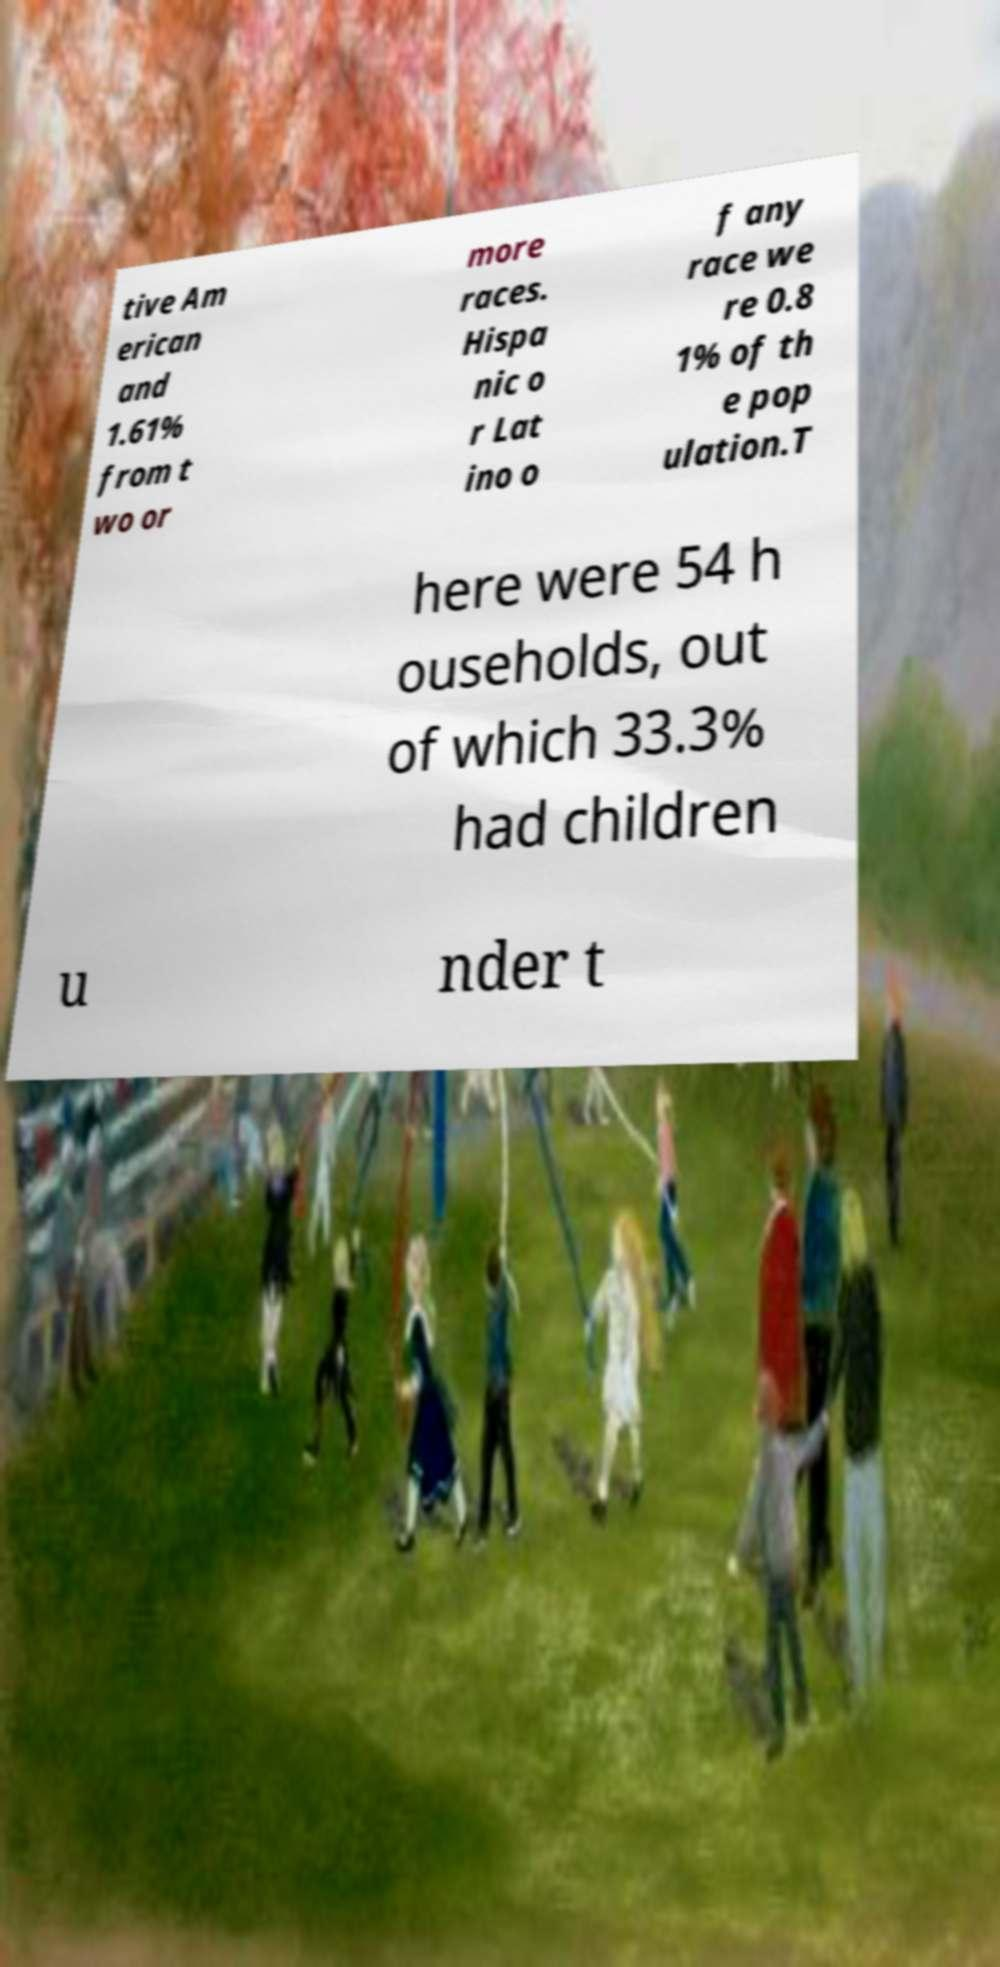What messages or text are displayed in this image? I need them in a readable, typed format. tive Am erican and 1.61% from t wo or more races. Hispa nic o r Lat ino o f any race we re 0.8 1% of th e pop ulation.T here were 54 h ouseholds, out of which 33.3% had children u nder t 